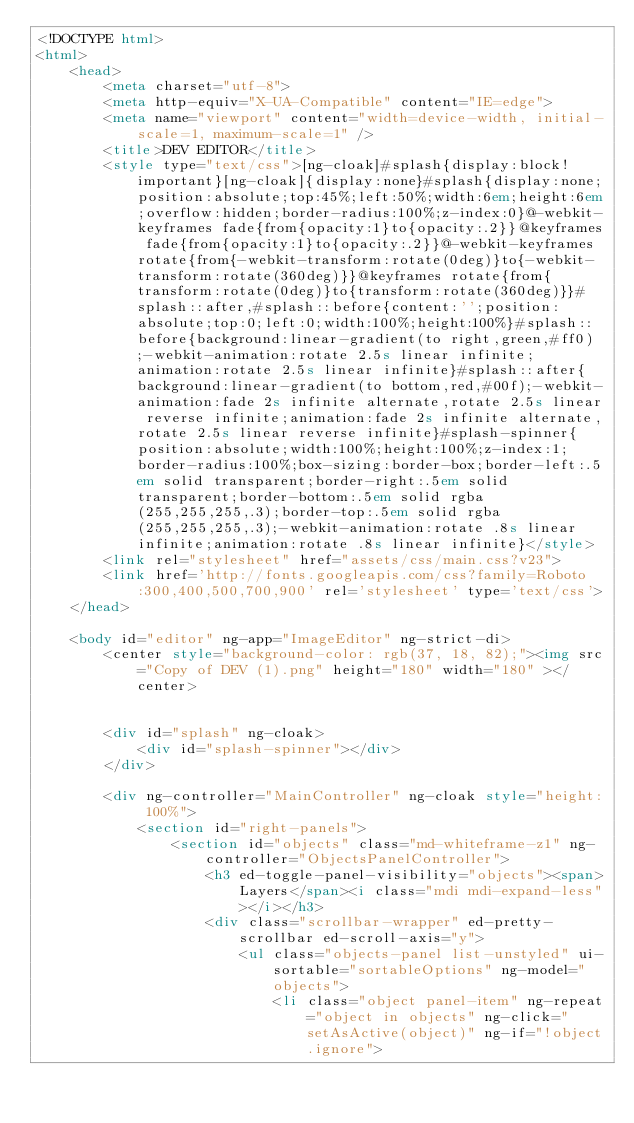Convert code to text. <code><loc_0><loc_0><loc_500><loc_500><_HTML_><!DOCTYPE html>
<html>
    <head>
        <meta charset="utf-8">
        <meta http-equiv="X-UA-Compatible" content="IE=edge">
        <meta name="viewport" content="width=device-width, initial-scale=1, maximum-scale=1" />
        <title>DEV EDITOR</title>
        <style type="text/css">[ng-cloak]#splash{display:block!important}[ng-cloak]{display:none}#splash{display:none;position:absolute;top:45%;left:50%;width:6em;height:6em;overflow:hidden;border-radius:100%;z-index:0}@-webkit-keyframes fade{from{opacity:1}to{opacity:.2}}@keyframes fade{from{opacity:1}to{opacity:.2}}@-webkit-keyframes rotate{from{-webkit-transform:rotate(0deg)}to{-webkit-transform:rotate(360deg)}}@keyframes rotate{from{transform:rotate(0deg)}to{transform:rotate(360deg)}}#splash::after,#splash::before{content:'';position:absolute;top:0;left:0;width:100%;height:100%}#splash::before{background:linear-gradient(to right,green,#ff0);-webkit-animation:rotate 2.5s linear infinite;animation:rotate 2.5s linear infinite}#splash::after{background:linear-gradient(to bottom,red,#00f);-webkit-animation:fade 2s infinite alternate,rotate 2.5s linear reverse infinite;animation:fade 2s infinite alternate,rotate 2.5s linear reverse infinite}#splash-spinner{position:absolute;width:100%;height:100%;z-index:1;border-radius:100%;box-sizing:border-box;border-left:.5em solid transparent;border-right:.5em solid transparent;border-bottom:.5em solid rgba(255,255,255,.3);border-top:.5em solid rgba(255,255,255,.3);-webkit-animation:rotate .8s linear infinite;animation:rotate .8s linear infinite}</style>
        <link rel="stylesheet" href="assets/css/main.css?v23">
        <link href='http://fonts.googleapis.com/css?family=Roboto:300,400,500,700,900' rel='stylesheet' type='text/css'>
    </head>

    <body id="editor" ng-app="ImageEditor" ng-strict-di>
        <center style="background-color: rgb(37, 18, 82);"><img src="Copy of DEV (1).png" height="180" width="180" ></center>


        <div id="splash" ng-cloak>
            <div id="splash-spinner"></div>
        </div>

        <div ng-controller="MainController" ng-cloak style="height: 100%">
            <section id="right-panels">
                <section id="objects" class="md-whiteframe-z1" ng-controller="ObjectsPanelController">
                    <h3 ed-toggle-panel-visibility="objects"><span>Layers</span><i class="mdi mdi-expand-less"></i></h3>
                    <div class="scrollbar-wrapper" ed-pretty-scrollbar ed-scroll-axis="y">
                        <ul class="objects-panel list-unstyled" ui-sortable="sortableOptions" ng-model="objects">
                            <li class="object panel-item" ng-repeat="object in objects" ng-click="setAsActive(object)" ng-if="!object.ignore"></code> 